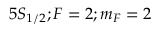Convert formula to latex. <formula><loc_0><loc_0><loc_500><loc_500>5 S _ { 1 / 2 } ; F = 2 ; m _ { F } = 2</formula> 